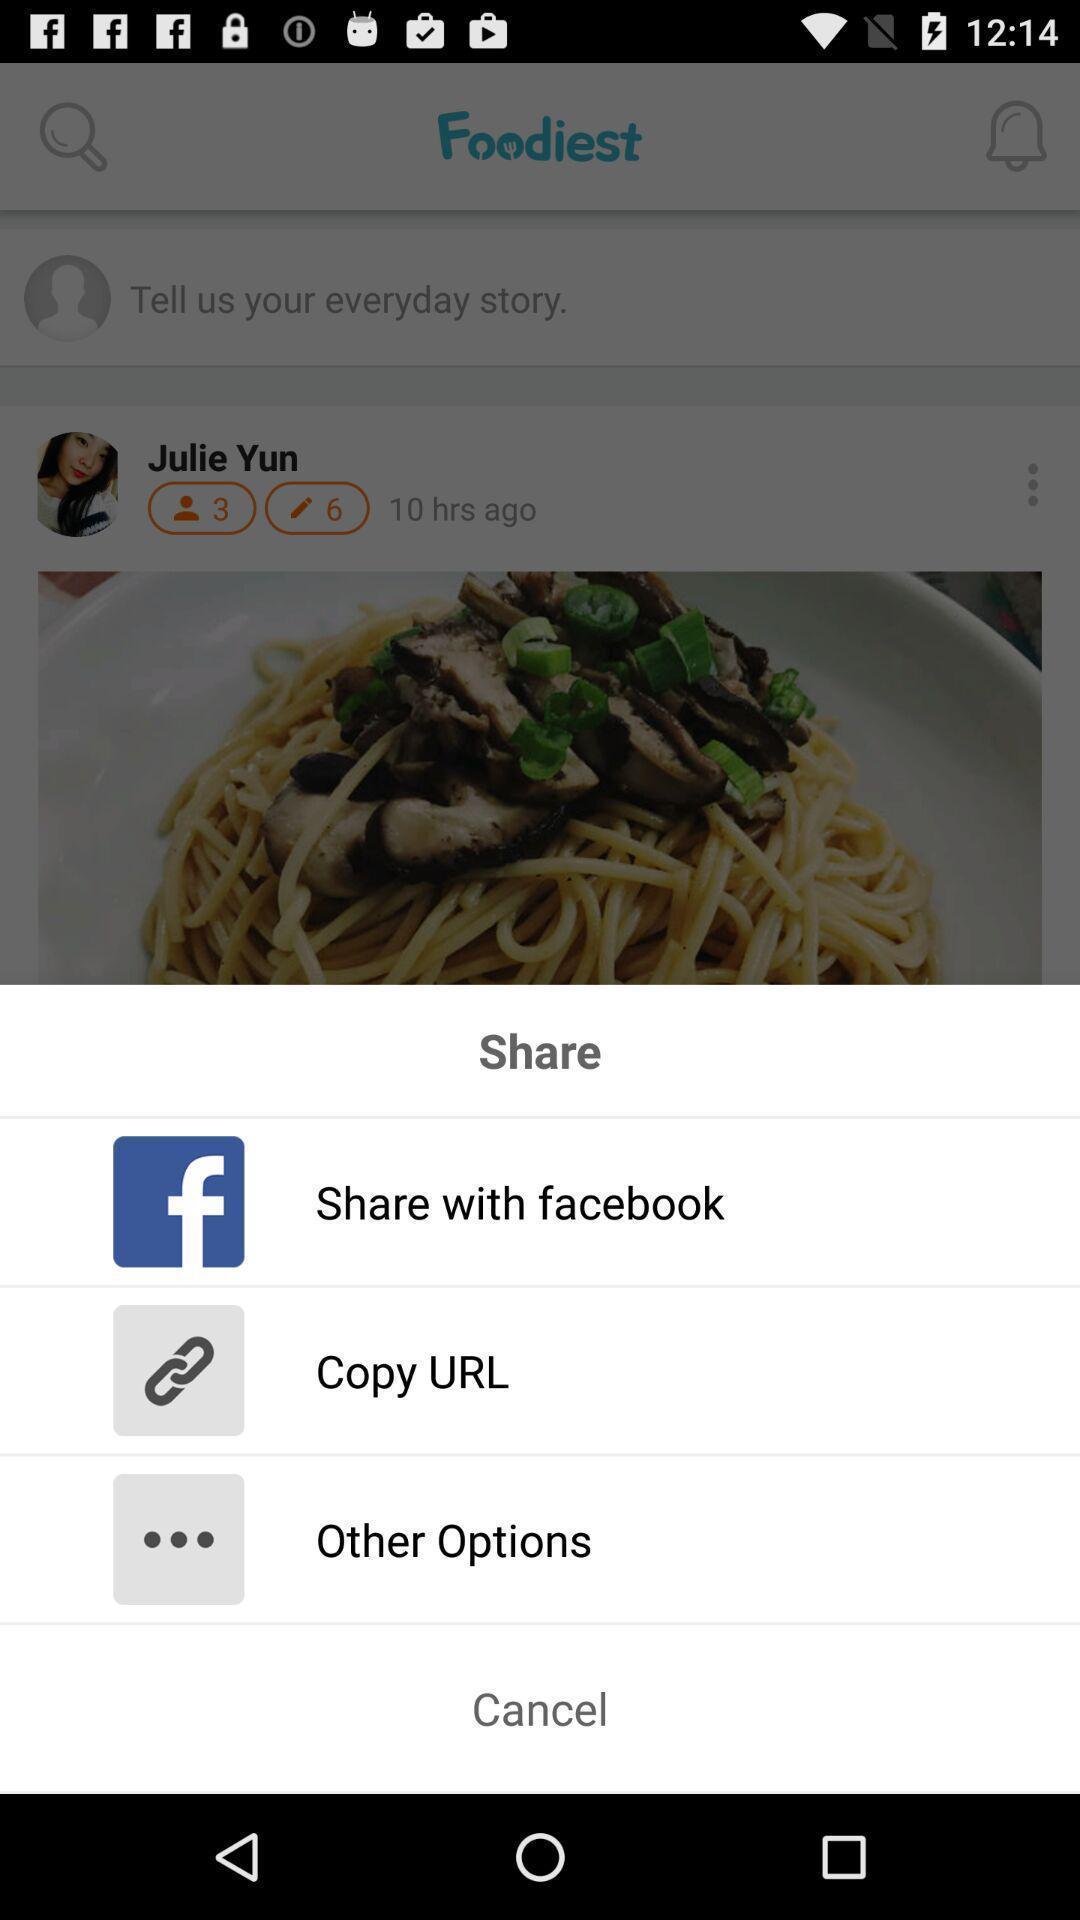Provide a description of this screenshot. Share foodiest information with social app. 